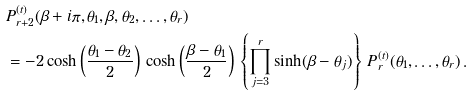<formula> <loc_0><loc_0><loc_500><loc_500>& P ^ { ( t ) } _ { r + 2 } ( \beta + i \pi , \theta _ { 1 } , \beta , \theta _ { 2 } , \dots , \theta _ { r } ) \\ & = - 2 \cosh \left ( \frac { \theta _ { 1 } - \theta _ { 2 } } { 2 } \right ) \, \cosh \left ( \frac { \beta - \theta _ { 1 } } { 2 } \right ) \, \left \{ \prod _ { j = 3 } ^ { r } \sinh ( \beta - \theta _ { j } ) \right \} \, P ^ { ( t ) } _ { r } ( \theta _ { 1 } , \dots , \theta _ { r } ) \, .</formula> 